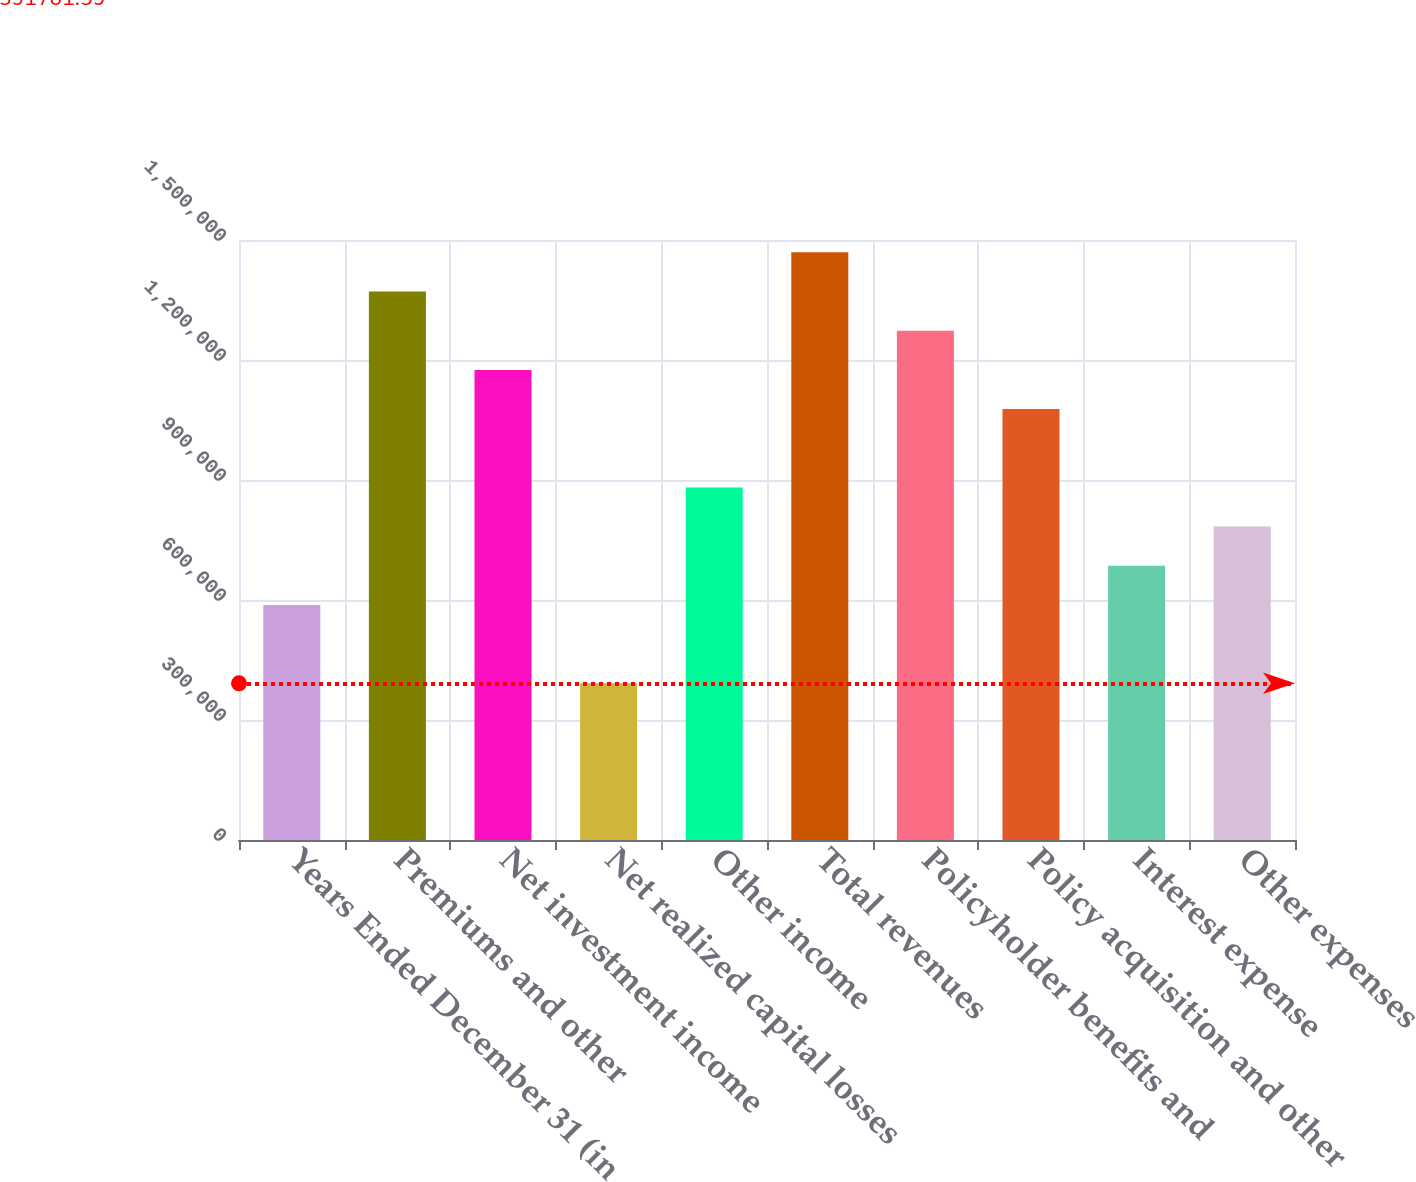Convert chart to OTSL. <chart><loc_0><loc_0><loc_500><loc_500><bar_chart><fcel>Years Ended December 31 (in<fcel>Premiums and other<fcel>Net investment income<fcel>Net realized capital losses<fcel>Other income<fcel>Total revenues<fcel>Policyholder benefits and<fcel>Policy acquisition and other<fcel>Interest expense<fcel>Other expenses<nl><fcel>587659<fcel>1.37117e+06<fcel>1.17529e+06<fcel>391781<fcel>881475<fcel>1.46911e+06<fcel>1.27323e+06<fcel>1.07735e+06<fcel>685598<fcel>783536<nl></chart> 